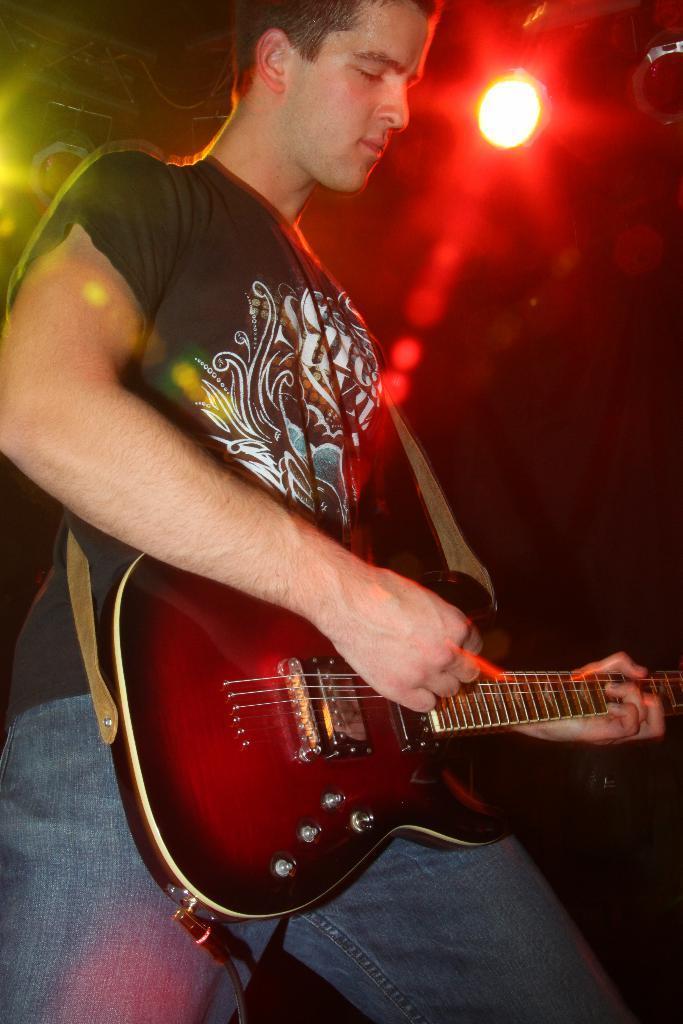Describe this image in one or two sentences. This is the picture of a man in black t shirt holding a guitar. Background of this man is a light which is in red color. 